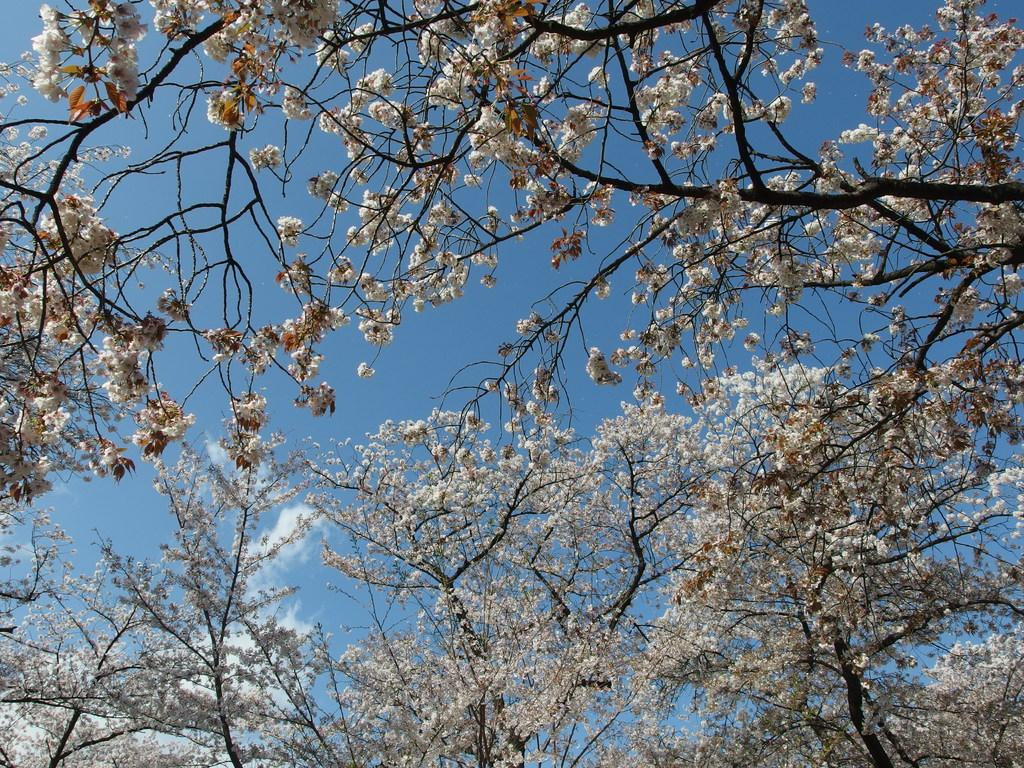What type of vegetation can be seen in the image? There are trees in the image. Are there any specific features of the trees? Yes, there are white flowers on the trees. What is visible at the top of the image? The sky is visible at the top of the image. What can be seen in the sky? Clouds are present in the sky. What hobbies does the fireman have in the image? There is no fireman present in the image; it features trees with white flowers and a sky with clouds. 